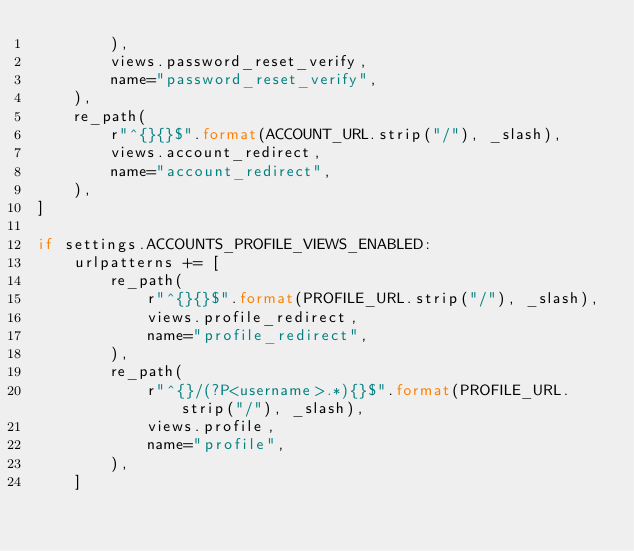<code> <loc_0><loc_0><loc_500><loc_500><_Python_>        ),
        views.password_reset_verify,
        name="password_reset_verify",
    ),
    re_path(
        r"^{}{}$".format(ACCOUNT_URL.strip("/"), _slash),
        views.account_redirect,
        name="account_redirect",
    ),
]

if settings.ACCOUNTS_PROFILE_VIEWS_ENABLED:
    urlpatterns += [
        re_path(
            r"^{}{}$".format(PROFILE_URL.strip("/"), _slash),
            views.profile_redirect,
            name="profile_redirect",
        ),
        re_path(
            r"^{}/(?P<username>.*){}$".format(PROFILE_URL.strip("/"), _slash),
            views.profile,
            name="profile",
        ),
    ]
</code> 